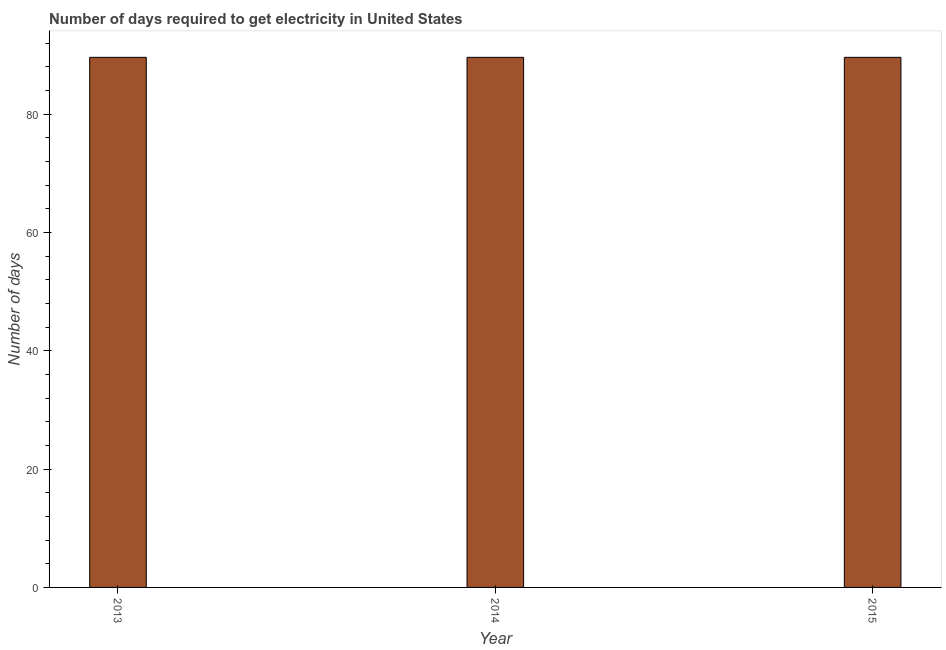Does the graph contain any zero values?
Offer a terse response. No. Does the graph contain grids?
Make the answer very short. No. What is the title of the graph?
Ensure brevity in your answer.  Number of days required to get electricity in United States. What is the label or title of the Y-axis?
Make the answer very short. Number of days. What is the time to get electricity in 2014?
Offer a very short reply. 89.6. Across all years, what is the maximum time to get electricity?
Ensure brevity in your answer.  89.6. Across all years, what is the minimum time to get electricity?
Keep it short and to the point. 89.6. In which year was the time to get electricity maximum?
Provide a short and direct response. 2013. What is the sum of the time to get electricity?
Your answer should be compact. 268.8. What is the difference between the time to get electricity in 2013 and 2014?
Your answer should be very brief. 0. What is the average time to get electricity per year?
Give a very brief answer. 89.6. What is the median time to get electricity?
Ensure brevity in your answer.  89.6. What is the ratio of the time to get electricity in 2014 to that in 2015?
Make the answer very short. 1. Is the time to get electricity in 2014 less than that in 2015?
Ensure brevity in your answer.  No. Is the difference between the time to get electricity in 2014 and 2015 greater than the difference between any two years?
Provide a short and direct response. Yes. What is the difference between the highest and the second highest time to get electricity?
Offer a terse response. 0. Is the sum of the time to get electricity in 2013 and 2015 greater than the maximum time to get electricity across all years?
Offer a very short reply. Yes. What is the difference between the highest and the lowest time to get electricity?
Make the answer very short. 0. How many bars are there?
Provide a succinct answer. 3. What is the difference between two consecutive major ticks on the Y-axis?
Provide a short and direct response. 20. What is the Number of days of 2013?
Give a very brief answer. 89.6. What is the Number of days in 2014?
Ensure brevity in your answer.  89.6. What is the Number of days in 2015?
Provide a short and direct response. 89.6. What is the difference between the Number of days in 2013 and 2015?
Make the answer very short. 0. What is the ratio of the Number of days in 2013 to that in 2014?
Keep it short and to the point. 1. What is the ratio of the Number of days in 2013 to that in 2015?
Your answer should be compact. 1. 